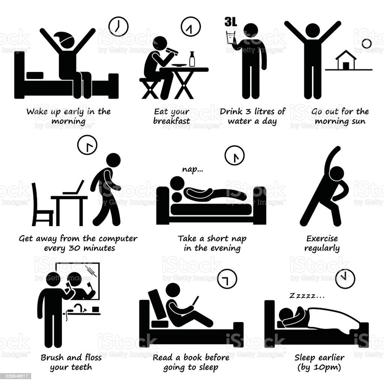How does taking a short nap in the evening contribute to one's overall health as depicted in the image? The image underscores the benefits of a short evening nap, suggesting it can help rejuvenate the body and mind, particularly if one wakes up early. Such naps can reduce stress, increase alertness, and improve cognitive function, making them a valuable addition to daily routines. 